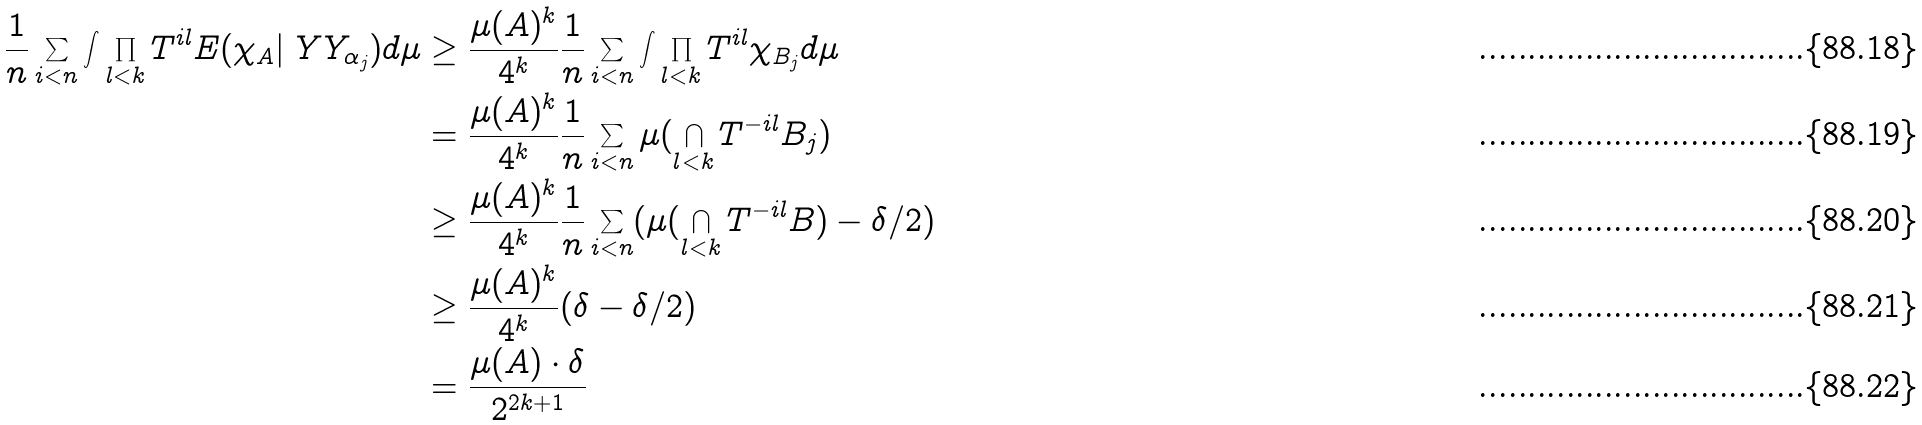<formula> <loc_0><loc_0><loc_500><loc_500>\frac { 1 } { n } \sum _ { i < n } \int \prod _ { l < k } T ^ { i l } E ( \chi _ { A } | \ Y Y _ { \alpha _ { j } } ) d \mu & \geq \frac { \mu ( A ) ^ { k } } { 4 ^ { k } } \frac { 1 } { n } \sum _ { i < n } \int \prod _ { l < k } T ^ { i l } \chi _ { B _ { j } } d \mu \\ & = \frac { \mu ( A ) ^ { k } } { 4 ^ { k } } \frac { 1 } { n } \sum _ { i < n } \mu ( \bigcap _ { l < k } T ^ { - i l } B _ { j } ) \\ & \geq \frac { \mu ( A ) ^ { k } } { 4 ^ { k } } \frac { 1 } { n } \sum _ { i < n } ( \mu ( \bigcap _ { l < k } T ^ { - i l } B ) - \delta / 2 ) \\ & \geq \frac { \mu ( A ) ^ { k } } { 4 ^ { k } } ( \delta - \delta / 2 ) \\ & = \frac { \mu ( A ) \cdot \delta } { 2 ^ { 2 k + 1 } }</formula> 